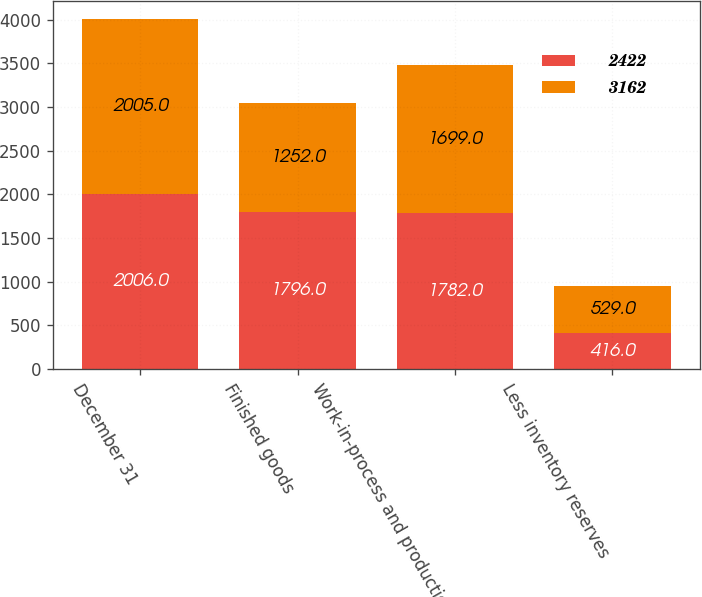Convert chart. <chart><loc_0><loc_0><loc_500><loc_500><stacked_bar_chart><ecel><fcel>December 31<fcel>Finished goods<fcel>Work-in-process and production<fcel>Less inventory reserves<nl><fcel>2422<fcel>2006<fcel>1796<fcel>1782<fcel>416<nl><fcel>3162<fcel>2005<fcel>1252<fcel>1699<fcel>529<nl></chart> 